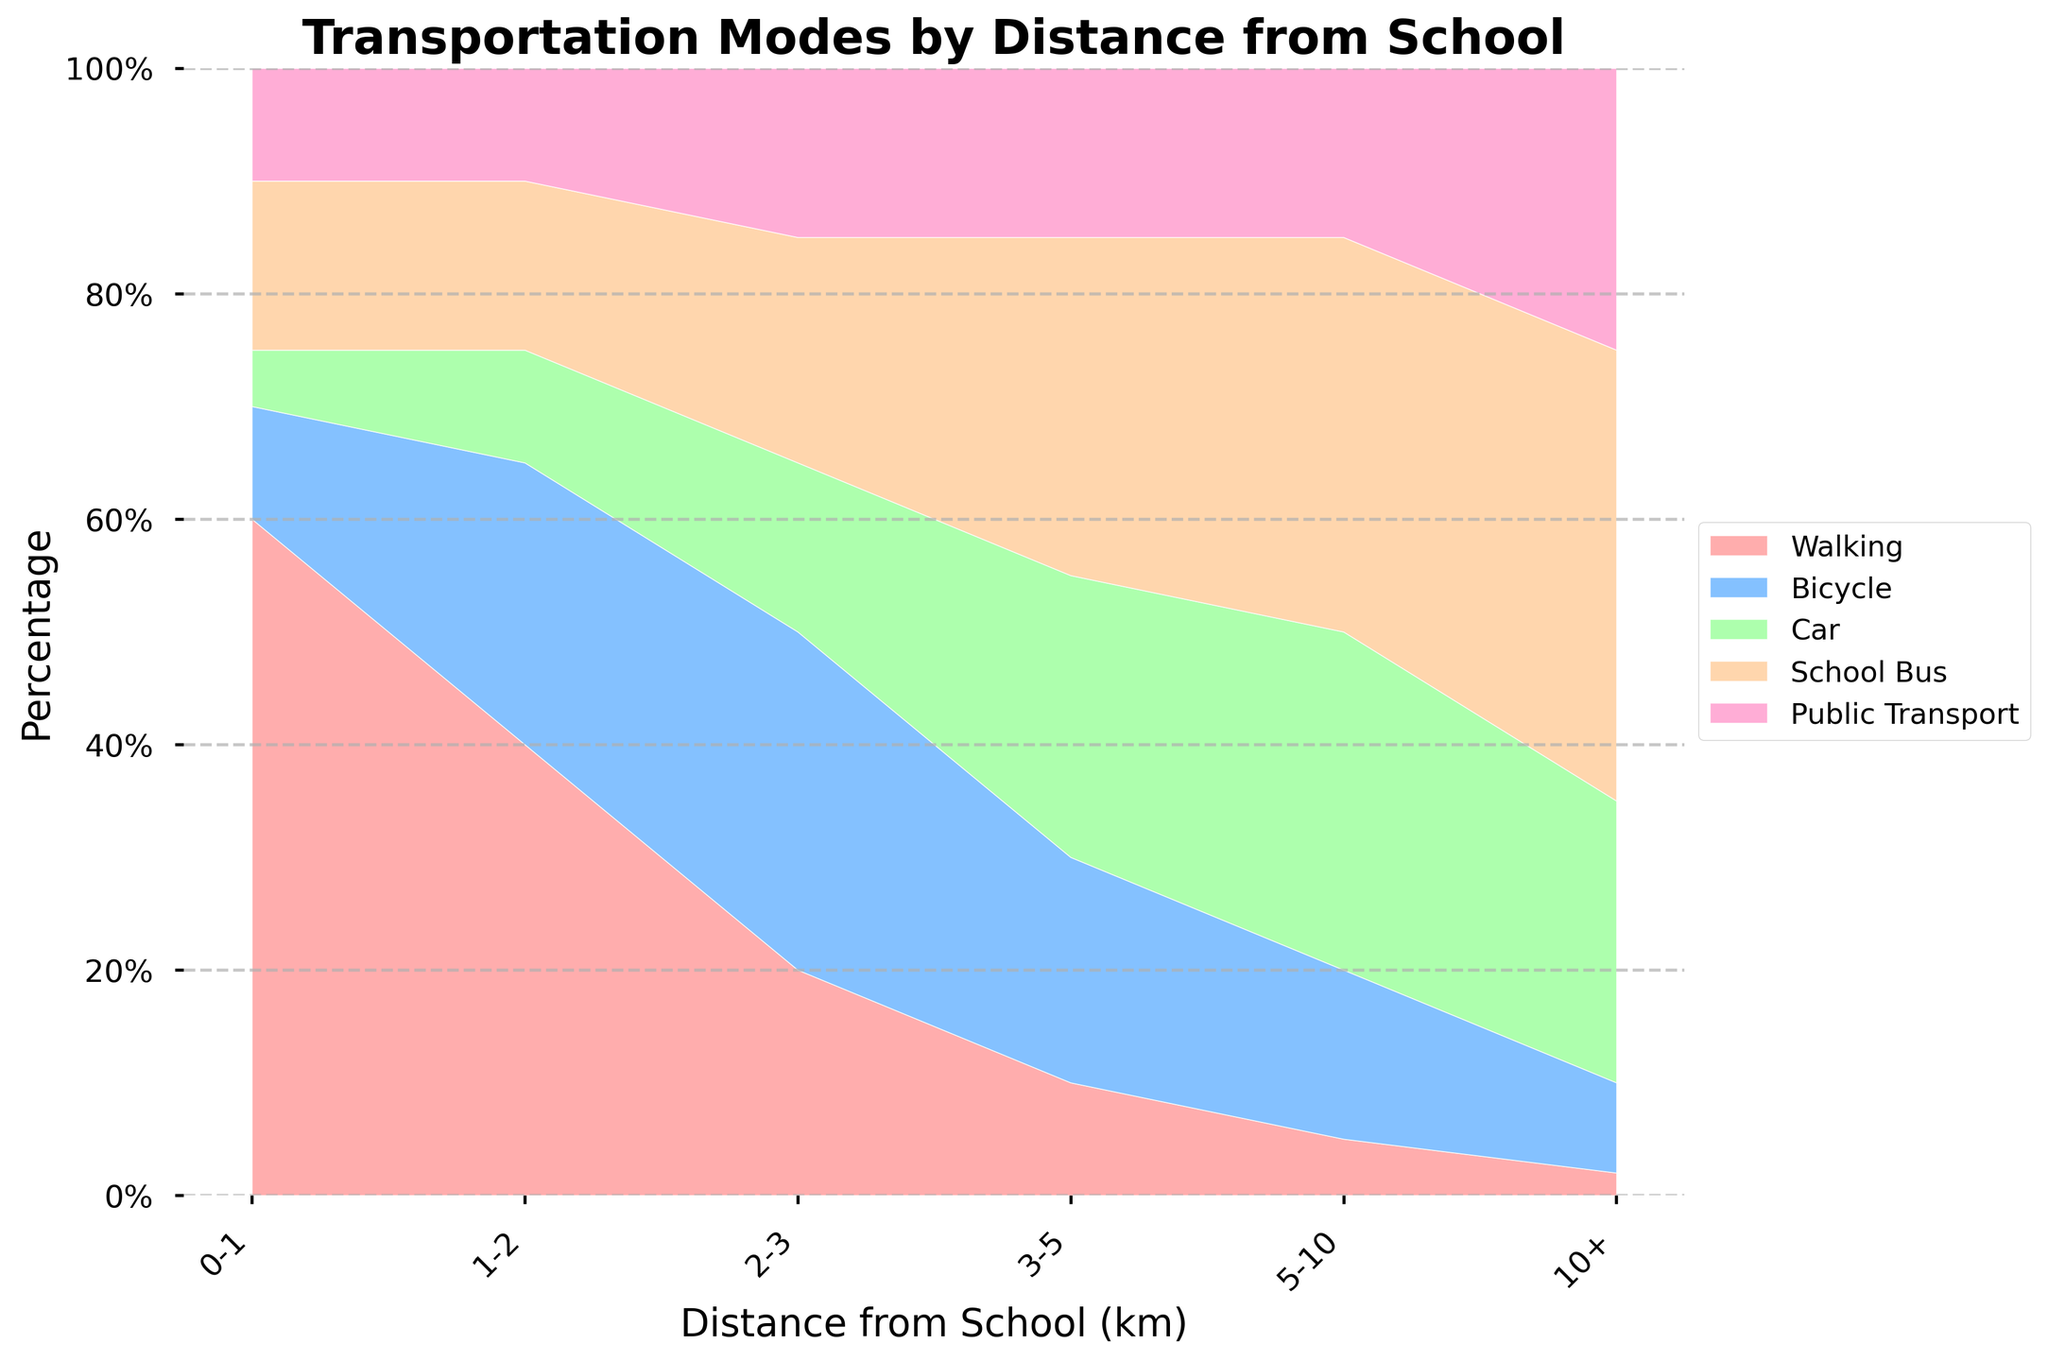What is the highest transportation mode percentage for distances of 0-1 km? The stacked area chart visually shows the largest segment for each distance range. For 0-1 km, 'Walking' has the largest area segment.
Answer: Walking What percentage of students use a car for distances of 5-10 km? Find the segment representing 'Car' for the distance range 5-10 km and check its height, which is approximately 30%.
Answer: 30% How does the percentage of students using public transport change from 2-3 km to 10+ km? Observe the 'Public Transport' segments for distances '2-3', '5-10', and '10+' km. The percentage increases from 15% to 25%.
Answer: Increases by 10% What transport mode is the most popular for distances of 10+ km? Look at the largest segment for the distance range 10+ km. 'School Bus' occupies the largest segment.
Answer: School Bus Which distance range has the highest percentage of students walking to school? Compare the 'Walking' segments across all distance ranges. The '0-1 km' segment has the largest area.
Answer: 0-1 km Is the percentage of students using a bicycle higher for distances 1-2 km or 2-3 km? Compare the 'Bicycle' segments for distances '1-2 km' and '2-3 km'. The '2-3 km' range has a higher percentage.
Answer: 2-3 km For which distance range does the percentage of students using cars exceed the percentage using bicycles? Compare 'Car' and 'Bicycle' segments for all distance ranges. For '3-5 km', '5-10 km', '10+ km', the 'Car' segment exceeds the 'Bicycle' segment.
Answer: 3-5 km, 5-10 km, 10+ km What is the combined percentage of students using either a car or school bus for the distance range of 3-5 km? For 3-5 km, add the percentages of students using 'Car' (25%) and 'School Bus' (30%).
Answer: 55% Which transport mode shows the least change in percentage from 0-1 km to 10+ km distance? Compare percentage changes for each mode across the 0-1 km and 10+ km distances. 'Walking' decreases drastically, 'Bicycle' decreases, 'Car' increases significantly, 'School Bus' increases, and 'Public Transport' increases. 'Public Transport' shows a slow increase from 10% to 25%.
Answer: Public Transport What is the approximate percentage of students who use either public transport or a school bus for 2-3 km? For the 2-3 km range, add percentages of 'Public Transport' (15%) and 'School Bus' (20%).
Answer: 35% 